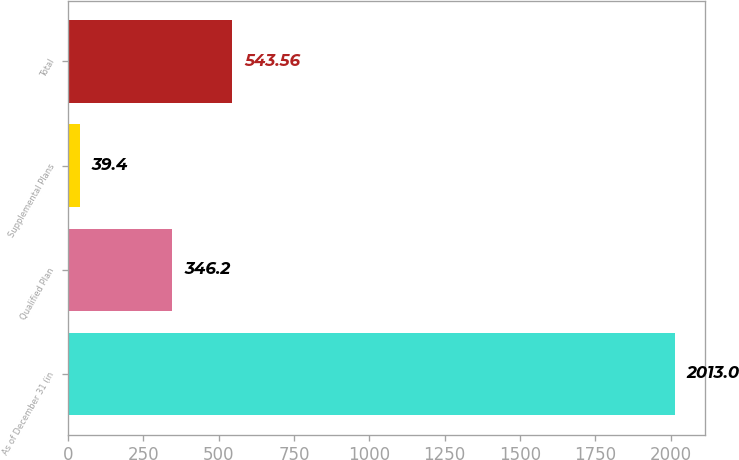Convert chart to OTSL. <chart><loc_0><loc_0><loc_500><loc_500><bar_chart><fcel>As of December 31 (in<fcel>Qualified Plan<fcel>Supplemental Plans<fcel>Total<nl><fcel>2013<fcel>346.2<fcel>39.4<fcel>543.56<nl></chart> 